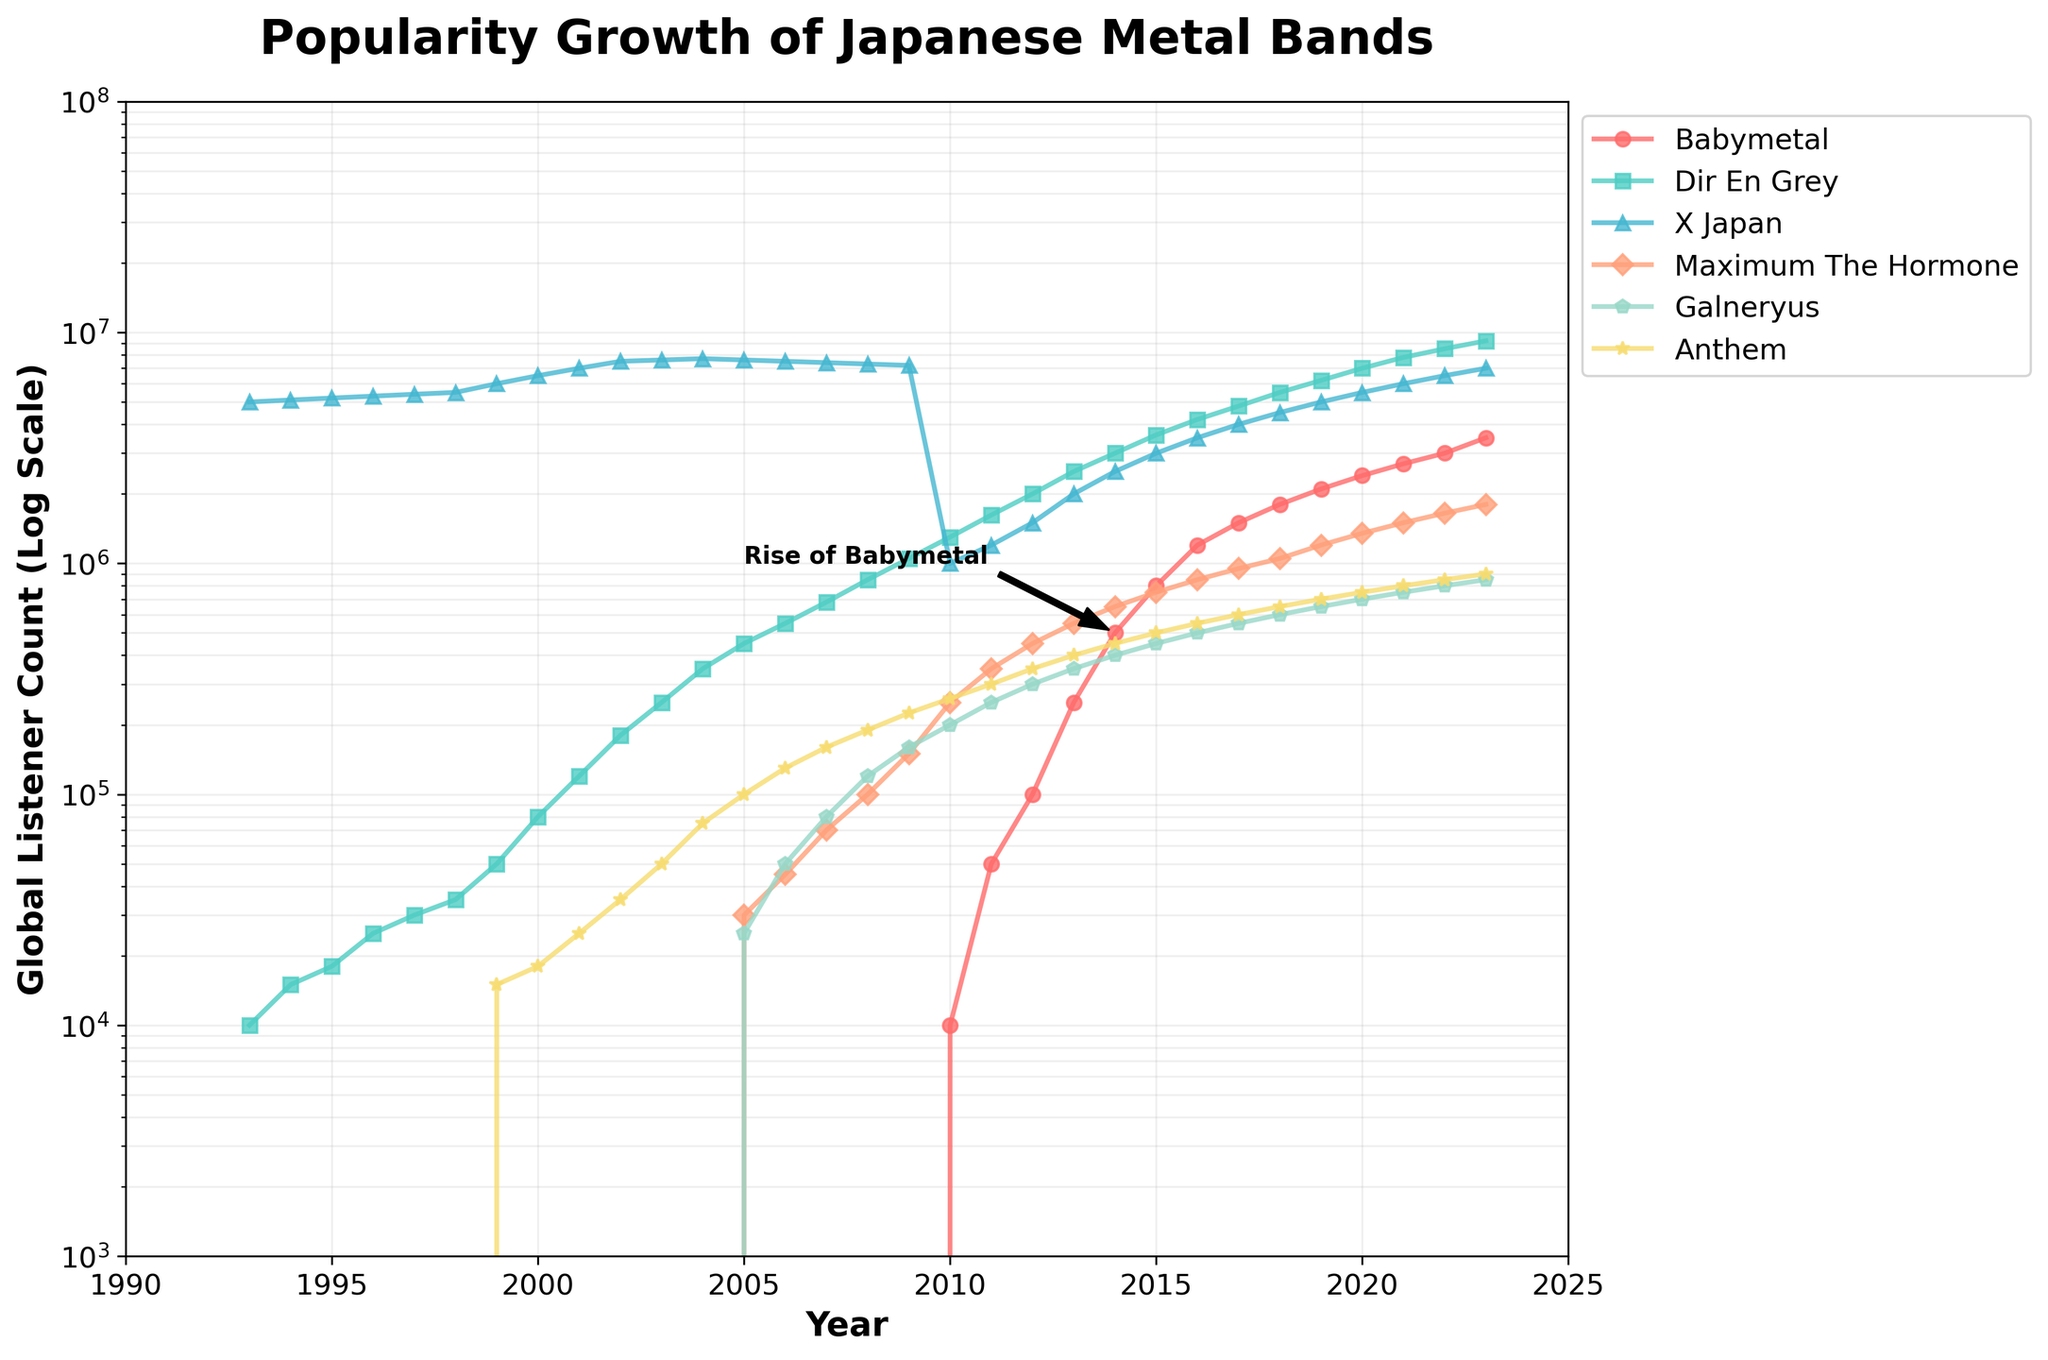What is the highest global listener count recorded for Babymetal? The highest global listener count for Babymetal can be found at the endpoint of the Babymetal line on the plot, which is 3,500,000 in the year 2023.
Answer: 3,500,000 How many bands surpassed 1,000,000 global listeners in 2010? To determine this, observe the y-values for each band in 2010 and see which ones exceed 1,000,000 global listeners. Only Dir En Grey with 1,300,000 listeners and X Japan with 1,000,000 listeners surpassed this count.
Answer: 2 Which band showed the most significant rise in popularity around 2014? Look for steep inclines around 2014. The line for Babymetal shows the most significant rise in this period, moving rapidly from around 250,000 in 2013 to 500,000 in 2014, with a clear annotation on the plot.
Answer: Babymetal What is the first year in which Dir En Grey reached 1,000,000 global listeners? Trace the line for Dir En Grey (color-coded turquoise) and find when the y-values first equal or exceed 1,000,000. In the year 2010, Dir En Grey hit 1,300,000 listeners.
Answer: 2010 In which era (pre-2000s vs. post-2000s) did X Japan have a higher average listener count? Calculate and compare the average listener counts for X Japan during pre-2000s (1993-1999) and post-2000s (2000-2023). The average for pre-2000s is around 5,485,714, and for post-2000s around 4,783,478, indicating a higher average in the pre-2000s era.
Answer: Pre-2000s How does the growth rate of Maximum The Hormone compare to Babymetal between 2010 and 2020? To compare growth rates, observe the slope of each band's line from 2010 to 2020. Babymetal's listener count surged more rapidly from 10,000 to 2,400,000, whereas Maximum The Hormone grew more moderately from 250,000 to 1,350,000.
Answer: Babymetal grew faster Which band had the least growth in global listeners during the entire 30-year period? Compare the initial and final data points for each band's line to determine the smallest difference. Anthem started with zero listeners in 1993 and reached only 900,000 by 2023, which is the least growth among the bands.
Answer: Anthem By what factor did the listener count of Galneryus increase from 2005 to 2023? First, find the listener counts for Galneryus in 2005 (25,000) and in 2023 (850,000). Calculate the factor by dividing 850,000 by 25,000, giving a growth factor of 34x.
Answer: 34 Which band's trajectory indicates a plateau in popularity in recent years? Look for a line that flattens out towards the recent years on the plot. X Japan's line shows a plateau, remaining relatively stable in the last few years around 7,000,000 listeners.
Answer: X Japan 